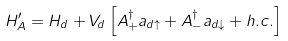Convert formula to latex. <formula><loc_0><loc_0><loc_500><loc_500>H _ { A } ^ { \prime } = H _ { d } + V _ { d } \left [ A _ { + } ^ { \dagger } a _ { d \uparrow } + A _ { - } ^ { \dagger } a _ { d \downarrow } + h . c . \right ]</formula> 